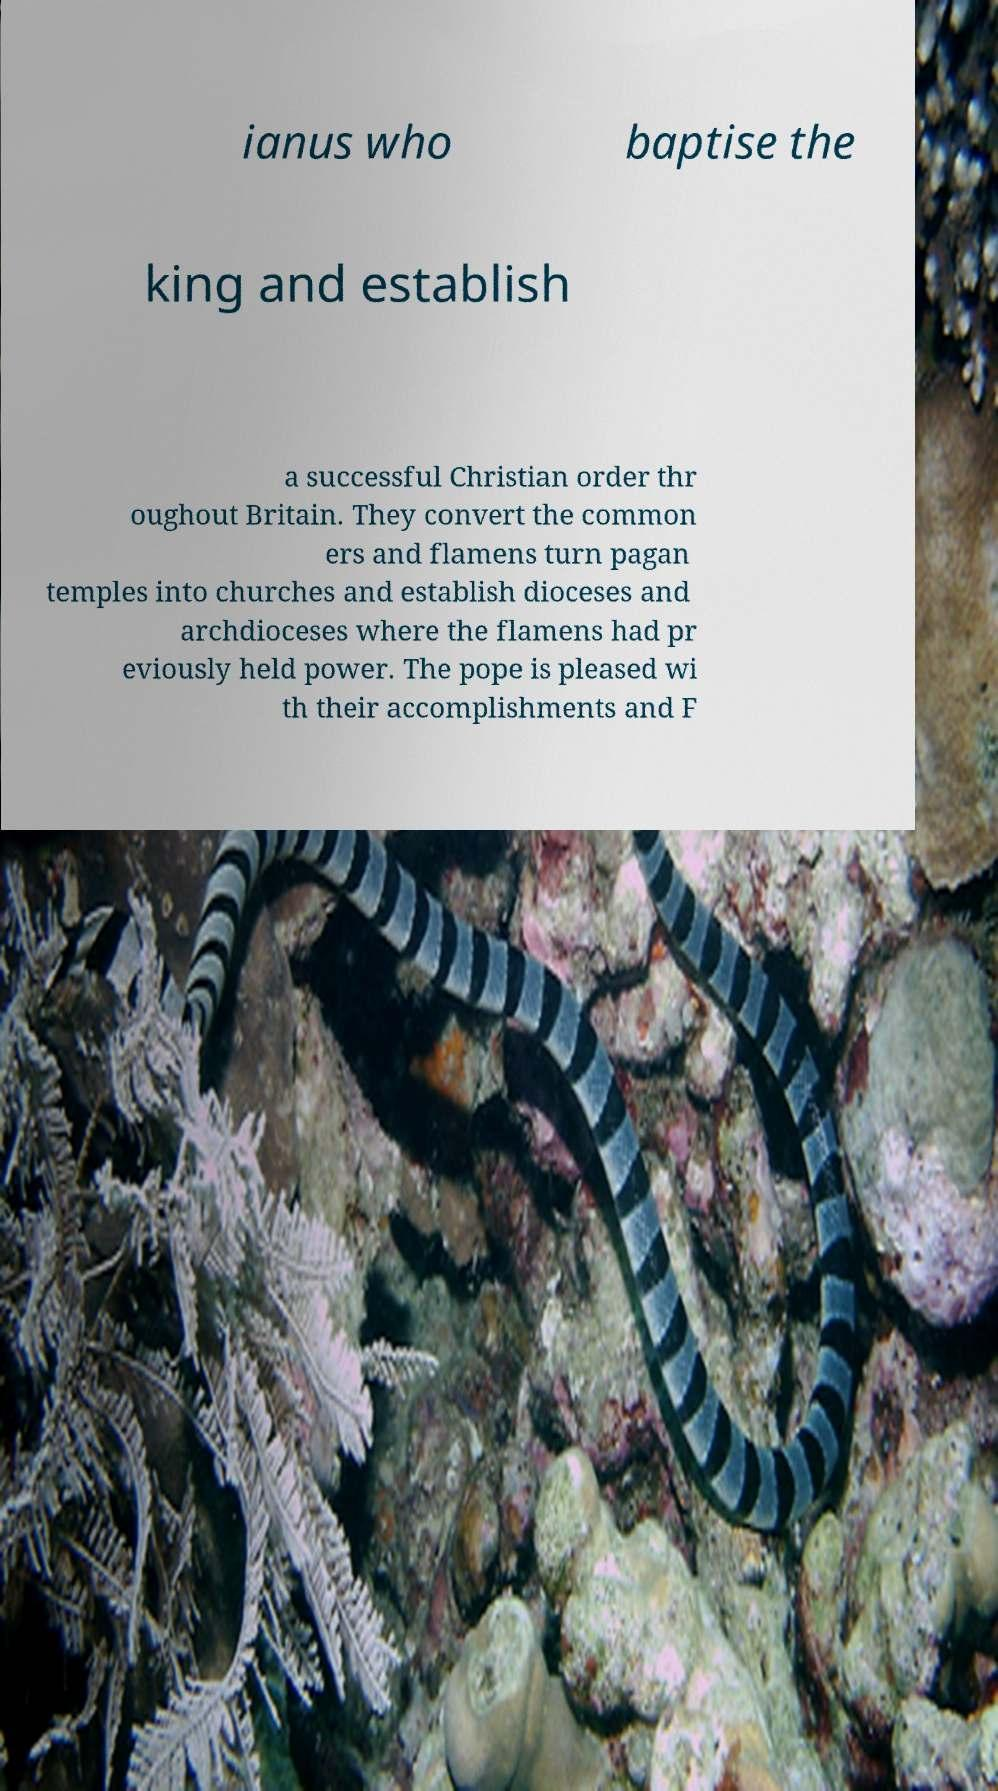Can you read and provide the text displayed in the image?This photo seems to have some interesting text. Can you extract and type it out for me? ianus who baptise the king and establish a successful Christian order thr oughout Britain. They convert the common ers and flamens turn pagan temples into churches and establish dioceses and archdioceses where the flamens had pr eviously held power. The pope is pleased wi th their accomplishments and F 